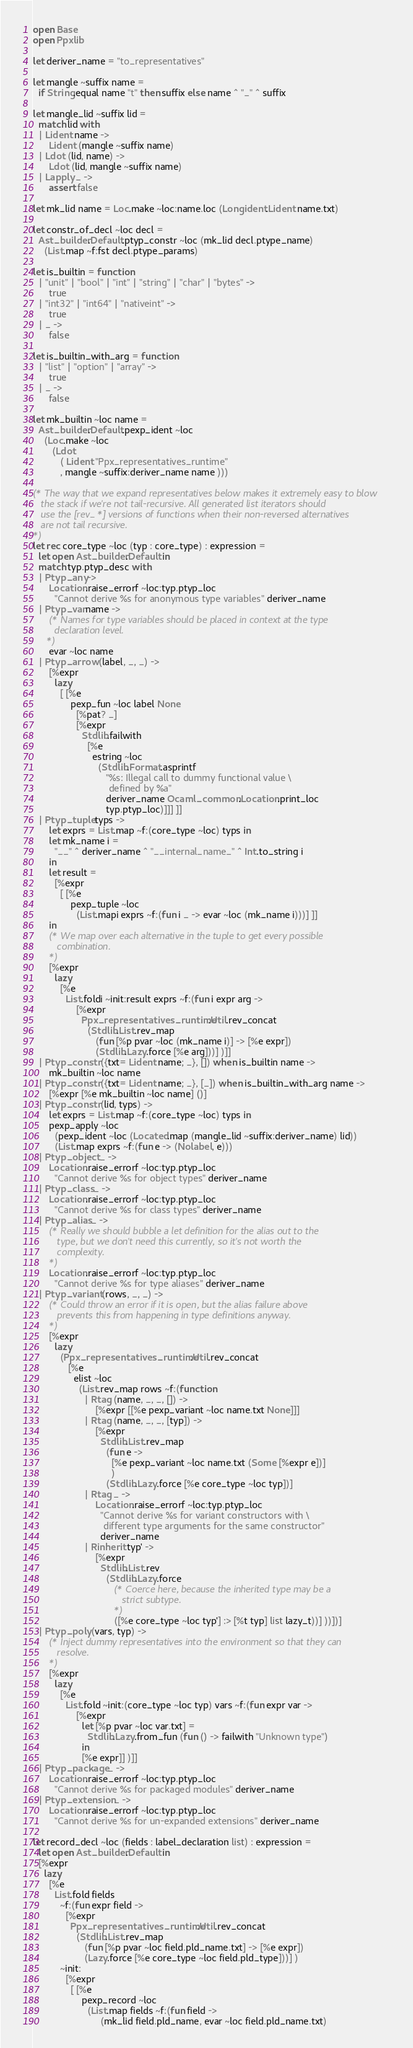<code> <loc_0><loc_0><loc_500><loc_500><_OCaml_>open Base
open Ppxlib

let deriver_name = "to_representatives"

let mangle ~suffix name =
  if String.equal name "t" then suffix else name ^ "_" ^ suffix

let mangle_lid ~suffix lid =
  match lid with
  | Lident name ->
      Lident (mangle ~suffix name)
  | Ldot (lid, name) ->
      Ldot (lid, mangle ~suffix name)
  | Lapply _ ->
      assert false

let mk_lid name = Loc.make ~loc:name.loc (Longident.Lident name.txt)

let constr_of_decl ~loc decl =
  Ast_builder.Default.ptyp_constr ~loc (mk_lid decl.ptype_name)
    (List.map ~f:fst decl.ptype_params)

let is_builtin = function
  | "unit" | "bool" | "int" | "string" | "char" | "bytes" ->
      true
  | "int32" | "int64" | "nativeint" ->
      true
  | _ ->
      false

let is_builtin_with_arg = function
  | "list" | "option" | "array" ->
      true
  | _ ->
      false

let mk_builtin ~loc name =
  Ast_builder.Default.pexp_ident ~loc
    (Loc.make ~loc
       (Ldot
          ( Lident "Ppx_representatives_runtime"
          , mangle ~suffix:deriver_name name )))

(* The way that we expand representatives below makes it extremely easy to blow
   the stack if we're not tail-recursive. All generated list iterators should
   use the [rev_*] versions of functions when their non-reversed alternatives
   are not tail recursive.
*)
let rec core_type ~loc (typ : core_type) : expression =
  let open Ast_builder.Default in
  match typ.ptyp_desc with
  | Ptyp_any ->
      Location.raise_errorf ~loc:typ.ptyp_loc
        "Cannot derive %s for anonymous type variables" deriver_name
  | Ptyp_var name ->
      (* Names for type variables should be placed in context at the type
        declaration level.
     *)
      evar ~loc name
  | Ptyp_arrow (label, _, _) ->
      [%expr
        lazy
          [ [%e
              pexp_fun ~loc label None
                [%pat? _]
                [%expr
                  Stdlib.failwith
                    [%e
                      estring ~loc
                        (Stdlib.Format.asprintf
                           "%s: Illegal call to dummy functional value \
                            defined by %a"
                           deriver_name Ocaml_common.Location.print_loc
                           typ.ptyp_loc)]]] ]]
  | Ptyp_tuple typs ->
      let exprs = List.map ~f:(core_type ~loc) typs in
      let mk_name i =
        "__" ^ deriver_name ^ "__internal_name_" ^ Int.to_string i
      in
      let result =
        [%expr
          [ [%e
              pexp_tuple ~loc
                (List.mapi exprs ~f:(fun i _ -> evar ~loc (mk_name i)))] ]]
      in
      (* We map over each alternative in the tuple to get every possible
         combination.
      *)
      [%expr
        lazy
          [%e
            List.foldi ~init:result exprs ~f:(fun i expr arg ->
                [%expr
                  Ppx_representatives_runtime.Util.rev_concat
                    (Stdlib.List.rev_map
                       (fun [%p pvar ~loc (mk_name i)] -> [%e expr])
                       (Stdlib.Lazy.force [%e arg]))] )]]
  | Ptyp_constr ({txt= Lident name; _}, []) when is_builtin name ->
      mk_builtin ~loc name
  | Ptyp_constr ({txt= Lident name; _}, [_]) when is_builtin_with_arg name ->
      [%expr [%e mk_builtin ~loc name] ()]
  | Ptyp_constr (lid, typs) ->
      let exprs = List.map ~f:(core_type ~loc) typs in
      pexp_apply ~loc
        (pexp_ident ~loc (Located.map (mangle_lid ~suffix:deriver_name) lid))
        (List.map exprs ~f:(fun e -> (Nolabel, e)))
  | Ptyp_object _ ->
      Location.raise_errorf ~loc:typ.ptyp_loc
        "Cannot derive %s for object types" deriver_name
  | Ptyp_class _ ->
      Location.raise_errorf ~loc:typ.ptyp_loc
        "Cannot derive %s for class types" deriver_name
  | Ptyp_alias _ ->
      (* Really we should bubble a let definition for the alias out to the
         type, but we don't need this currently, so it's not worth the
         complexity.
      *)
      Location.raise_errorf ~loc:typ.ptyp_loc
        "Cannot derive %s for type aliases" deriver_name
  | Ptyp_variant (rows, _, _) ->
      (* Could throw an error if it is open, but the alias failure above
         prevents this from happening in type definitions anyway.
      *)
      [%expr
        lazy
          (Ppx_representatives_runtime.Util.rev_concat
             [%e
               elist ~loc
                 (List.rev_map rows ~f:(function
                   | Rtag (name, _, _, []) ->
                       [%expr [[%e pexp_variant ~loc name.txt None]]]
                   | Rtag (name, _, _, [typ]) ->
                       [%expr
                         Stdlib.List.rev_map
                           (fun e ->
                             [%e pexp_variant ~loc name.txt (Some [%expr e])]
                             )
                           (Stdlib.Lazy.force [%e core_type ~loc typ])]
                   | Rtag _ ->
                       Location.raise_errorf ~loc:typ.ptyp_loc
                         "Cannot derive %s for variant constructors with \
                          different type arguments for the same constructor"
                         deriver_name
                   | Rinherit typ' ->
                       [%expr
                         Stdlib.List.rev
                           (Stdlib.Lazy.force
                              (* Coerce here, because the inherited type may be a
                                 strict subtype.
                              *)
                              ([%e core_type ~loc typ'] :> [%t typ] list lazy_t))] ))])]
  | Ptyp_poly (vars, typ) ->
      (* Inject dummy representatives into the environment so that they can
         resolve.
      *)
      [%expr
        lazy
          [%e
            List.fold ~init:(core_type ~loc typ) vars ~f:(fun expr var ->
                [%expr
                  let [%p pvar ~loc var.txt] =
                    Stdlib.Lazy.from_fun (fun () -> failwith "Unknown type")
                  in
                  [%e expr]] )]]
  | Ptyp_package _ ->
      Location.raise_errorf ~loc:typ.ptyp_loc
        "Cannot derive %s for packaged modules" deriver_name
  | Ptyp_extension _ ->
      Location.raise_errorf ~loc:typ.ptyp_loc
        "Cannot derive %s for un-expanded extensions" deriver_name

let record_decl ~loc (fields : label_declaration list) : expression =
  let open Ast_builder.Default in
  [%expr
    lazy
      [%e
        List.fold fields
          ~f:(fun expr field ->
            [%expr
              Ppx_representatives_runtime.Util.rev_concat
                (Stdlib.List.rev_map
                   (fun [%p pvar ~loc field.pld_name.txt] -> [%e expr])
                   (Lazy.force [%e core_type ~loc field.pld_type]))] )
          ~init:
            [%expr
              [ [%e
                  pexp_record ~loc
                    (List.map fields ~f:(fun field ->
                         (mk_lid field.pld_name, evar ~loc field.pld_name.txt)</code> 